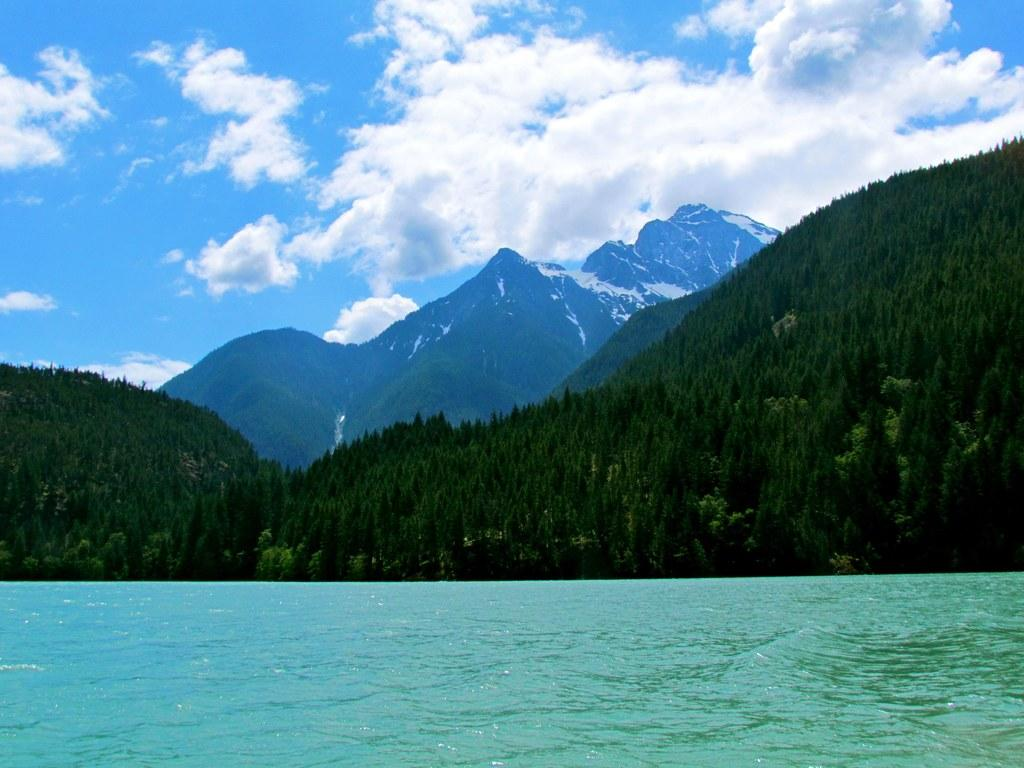What type of natural environment is depicted in the image? There is greenery in the image, which suggests a natural environment. What can be seen in the distance in the image? There are mountains in the background of the image. What body of water is visible in the image? There is water visible in the image. What is the color of the sky in the image? The sky is blue in color. Are there any clouds in the sky in the image? Yes, the sky is cloudy in the image. How many tickets are visible in the image? There are no tickets present in the image. What type of print can be seen on the mountains in the image? There is no print on the mountains in the image; they are depicted as natural formations. 